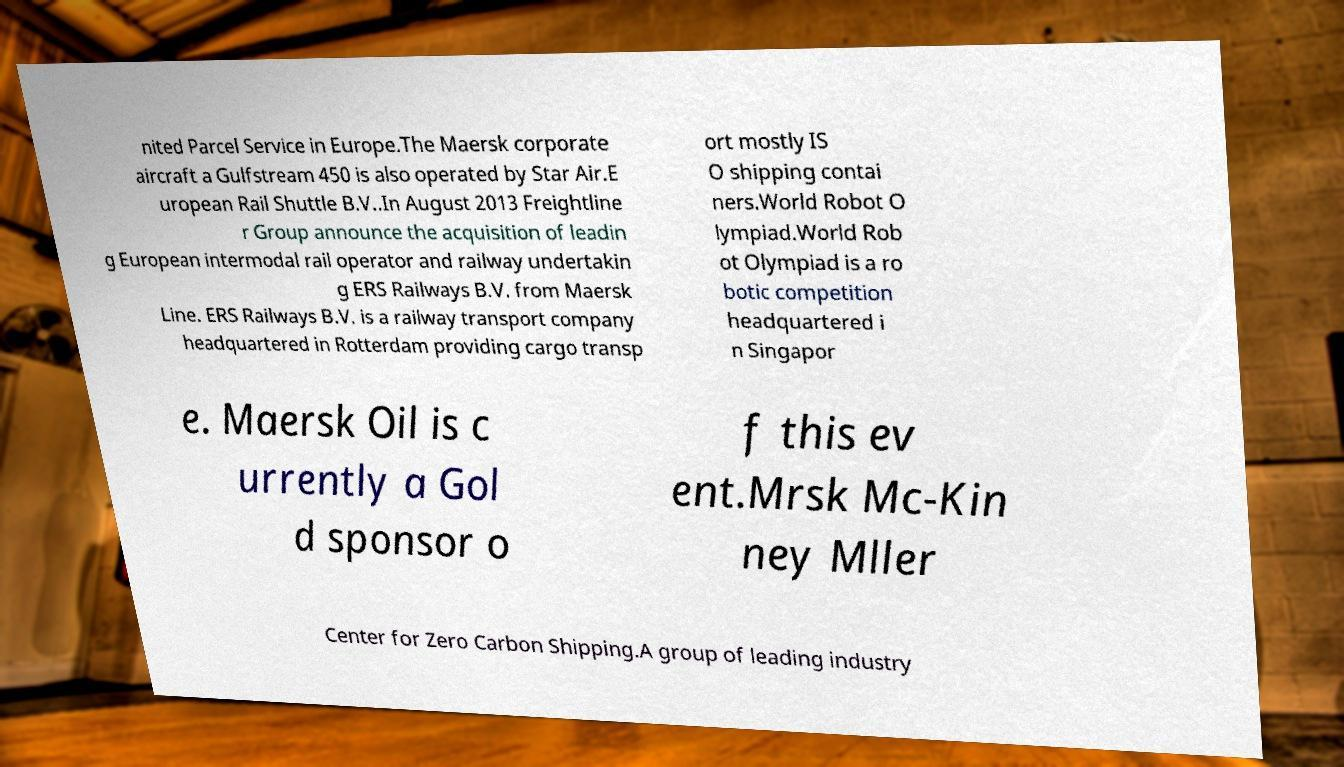Could you assist in decoding the text presented in this image and type it out clearly? nited Parcel Service in Europe.The Maersk corporate aircraft a Gulfstream 450 is also operated by Star Air.E uropean Rail Shuttle B.V..In August 2013 Freightline r Group announce the acquisition of leadin g European intermodal rail operator and railway undertakin g ERS Railways B.V. from Maersk Line. ERS Railways B.V. is a railway transport company headquartered in Rotterdam providing cargo transp ort mostly IS O shipping contai ners.World Robot O lympiad.World Rob ot Olympiad is a ro botic competition headquartered i n Singapor e. Maersk Oil is c urrently a Gol d sponsor o f this ev ent.Mrsk Mc-Kin ney Mller Center for Zero Carbon Shipping.A group of leading industry 